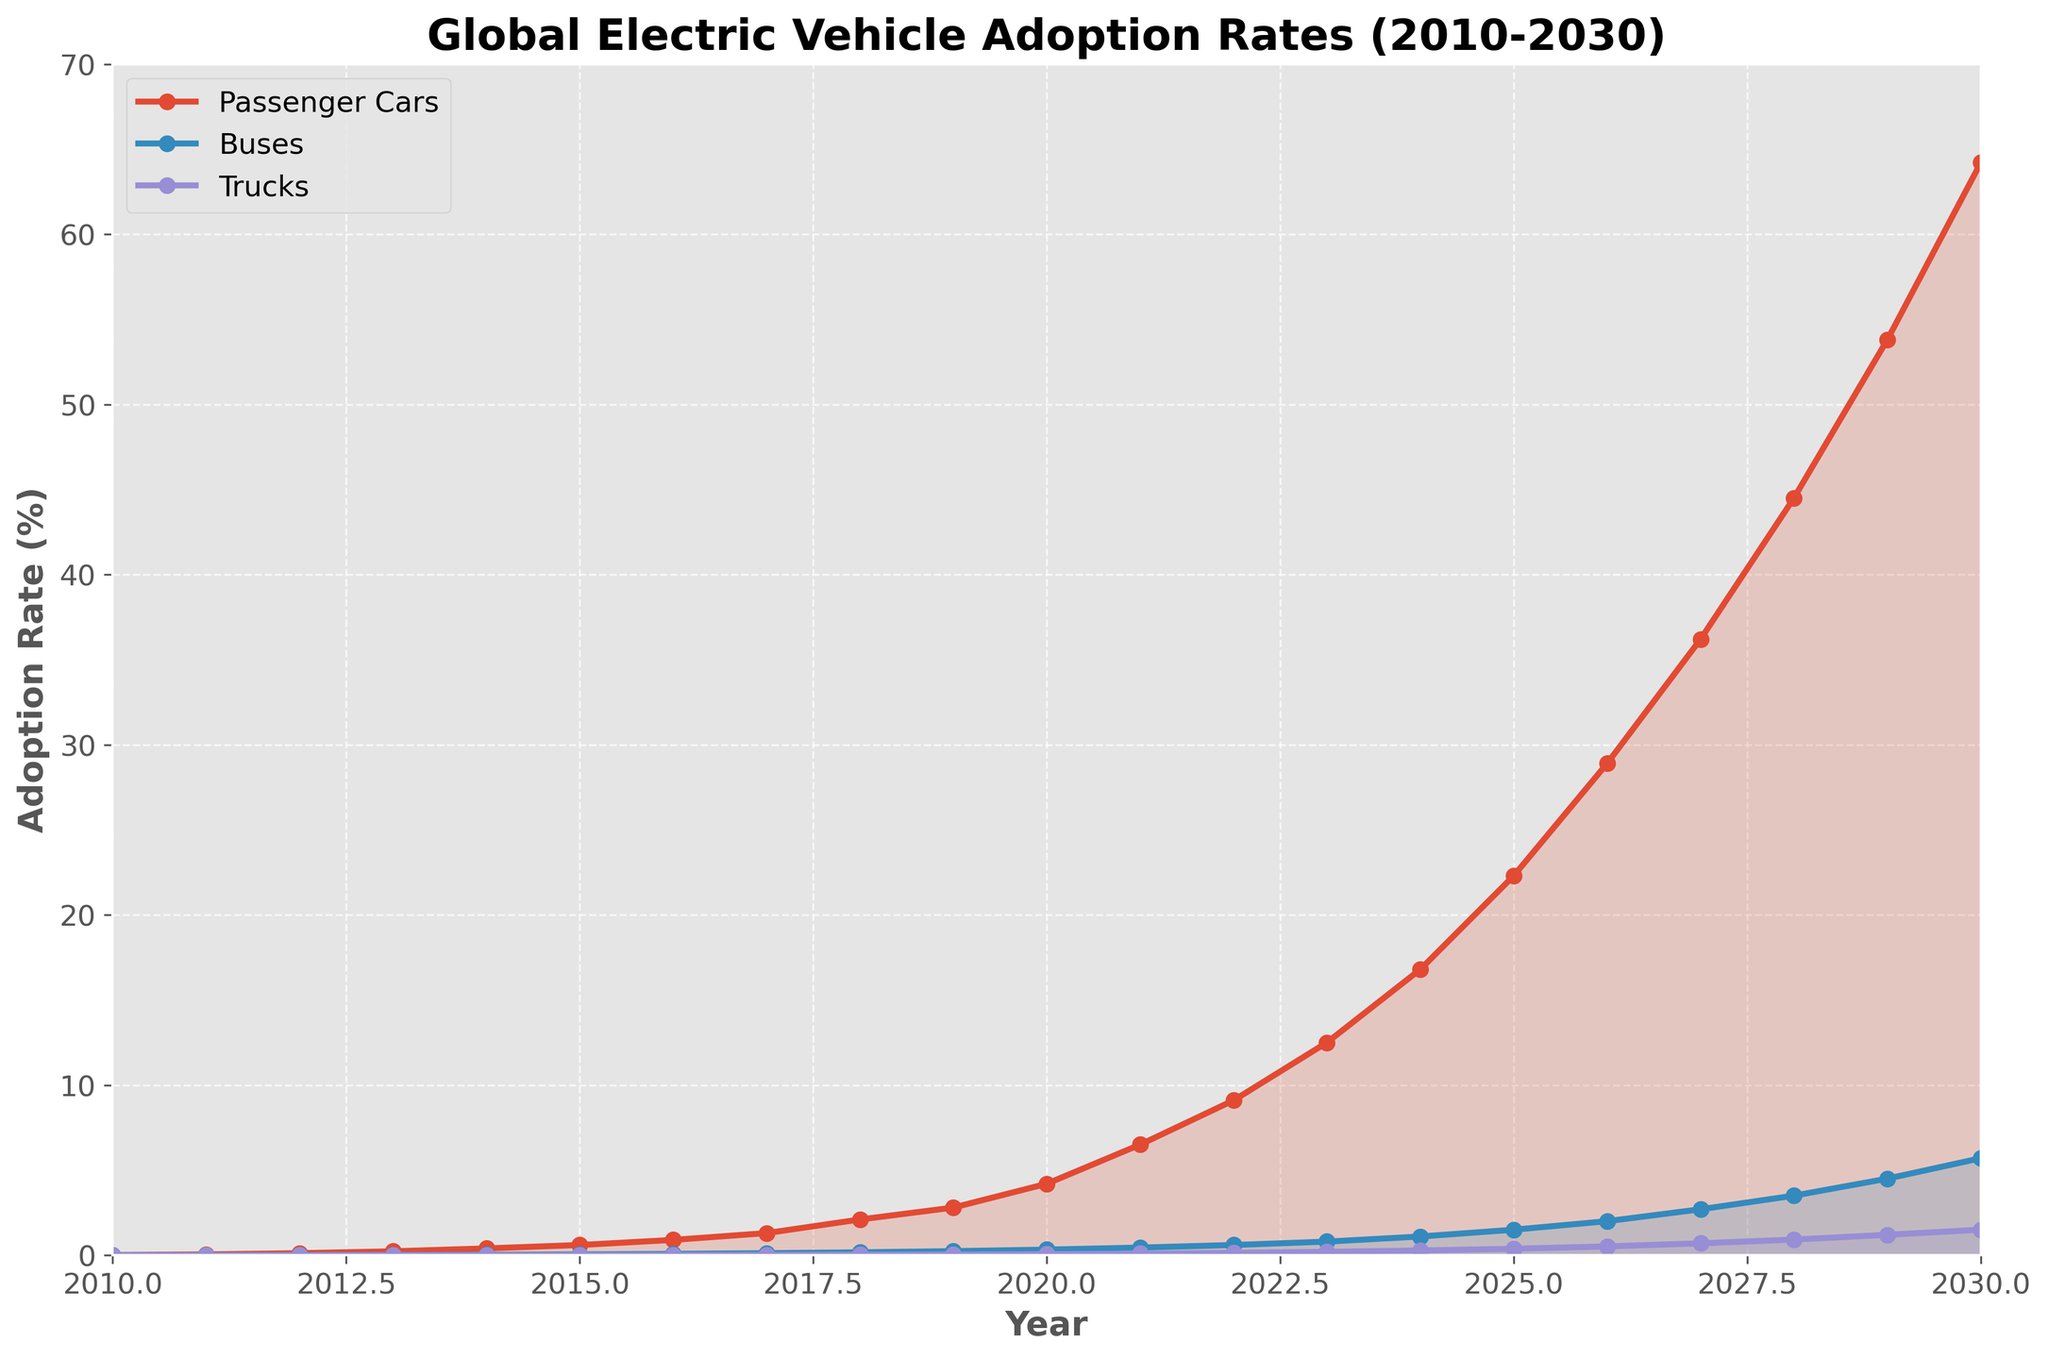What is the difference in adoption rate between passenger cars and buses in 2020? In 2020, the adoption rate for passenger cars is 4.2%, and for buses, it is 0.33%. Subtracting the two gives 4.2 - 0.33 = 3.87%
Answer: 3.87% Which vehicle type has the highest adoption rate in 2030, and what is the value? By looking at the plot in 2030, passenger cars have the highest adoption rate with a value of 64.2%
Answer: Passenger cars, 64.2% Compare the adoption rates of trucks and buses in 2015 and determine which one had the higher rate. In 2015, the adoption rate for trucks is 0.01%, and for buses, it is 0.05%. Buses have a higher adoption rate than trucks
Answer: Buses What is the average adoption rate of trucks from 2010 to 2020? Summing the adoption rates of trucks from 2010 to 2020: 0.001 + 0.002 + 0.003 + 0.005 + 0.008 + 0.01 + 0.015 + 0.02 + 0.03 + 0.04 + 0.06 = 0.194. Dividing by the number of years (11) gives 0.194/11 ≈ 0.0176%
Answer: 0.0176% By how much did the adoption rate of passenger cars increase between 2014 and 2018? The adoption rate of passenger cars in 2014 is 0.4% and in 2018 it is 2.1%. The increase is 2.1 - 0.4 = 1.7%
Answer: 1.7% What is the midway year where the adoption rate of passenger cars crossed 50%? By looking at the plot, in 2028, the adoption rate of passenger cars is 44.5%, and in 2029, it is 53.8%. Thus, 2029 is the year where it crosses 50%.
Answer: 2029 Which vehicle type shows the slowest adoption growth from 2010 to 2030? By comparing the slopes of the lines for passenger cars, buses, and trucks, the line for trucks shows the slowest increase in adoption rate
Answer: Trucks What is the combined adoption rate of all three vehicle types in 2025? In 2025, the adoption rates are: Passenger Cars: 22.3%, Buses: 1.5%, Trucks: 0.38%. Adding these gives 22.3 + 1.5 + 0.38 = 24.18%
Answer: 24.18% How many years did it take for the adoption rate of buses to increase from 0.002% to 3.5%? The adoption rate for buses is 0.002% in 2010 and 3.5% in 2028. It takes 2028 - 2010 = 18 years
Answer: 18 years 